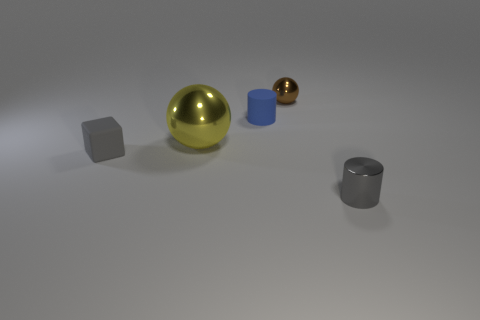Is there anything else that is the same size as the yellow shiny sphere?
Provide a short and direct response. No. There is a brown thing that is the same material as the yellow ball; what shape is it?
Your answer should be compact. Sphere. Is the cube the same size as the matte cylinder?
Your answer should be very brief. Yes. Is the material of the small gray thing to the left of the brown metal ball the same as the large thing?
Provide a succinct answer. No. There is a small gray object in front of the gray object left of the small brown metal ball; what number of small brown objects are in front of it?
Your answer should be compact. 0. There is a object that is in front of the gray cube; does it have the same shape as the small brown metallic object?
Offer a very short reply. No. What number of objects are gray things or gray things that are right of the large metal object?
Keep it short and to the point. 2. Are there more spheres in front of the brown metal ball than red matte balls?
Offer a terse response. Yes. Are there an equal number of shiny objects left of the small brown object and large things on the left side of the small gray metallic cylinder?
Make the answer very short. Yes. There is a small cylinder in front of the large object; are there any rubber objects that are to the right of it?
Make the answer very short. No. 